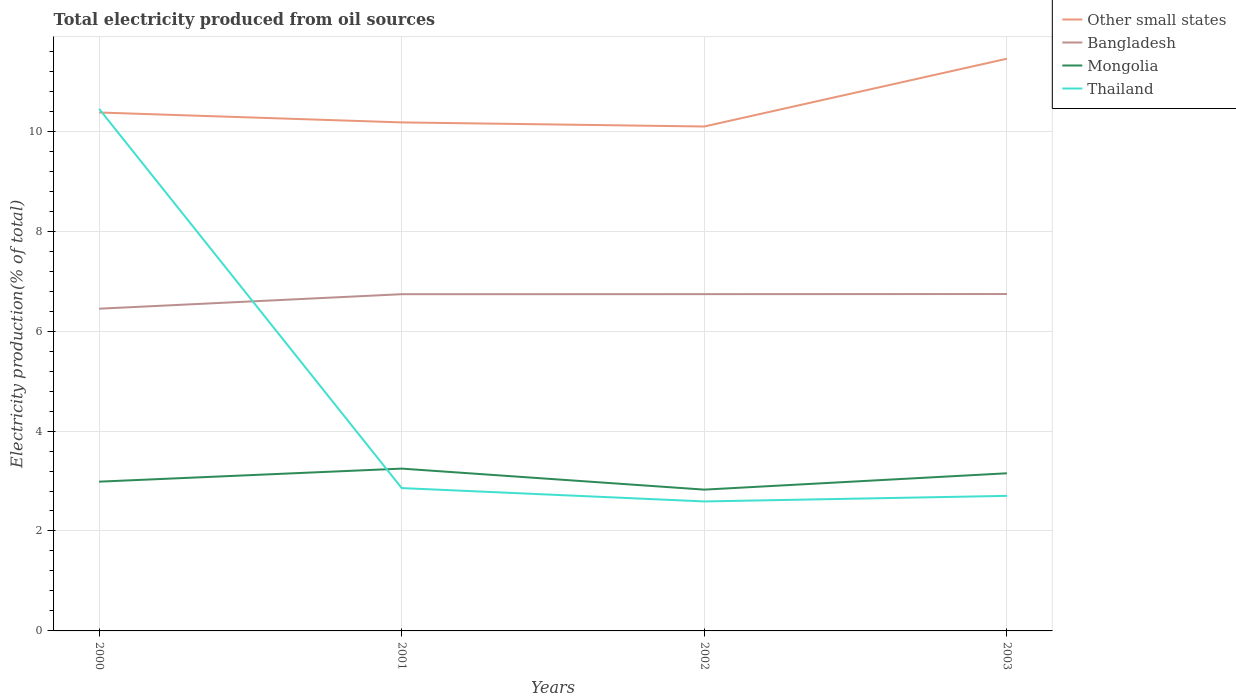Is the number of lines equal to the number of legend labels?
Make the answer very short. Yes. Across all years, what is the maximum total electricity produced in Bangladesh?
Ensure brevity in your answer.  6.45. In which year was the total electricity produced in Other small states maximum?
Ensure brevity in your answer.  2002. What is the total total electricity produced in Thailand in the graph?
Make the answer very short. 7.75. What is the difference between the highest and the second highest total electricity produced in Other small states?
Your answer should be compact. 1.36. What is the difference between the highest and the lowest total electricity produced in Thailand?
Give a very brief answer. 1. Is the total electricity produced in Bangladesh strictly greater than the total electricity produced in Mongolia over the years?
Ensure brevity in your answer.  No. How many lines are there?
Provide a succinct answer. 4. How many years are there in the graph?
Ensure brevity in your answer.  4. Are the values on the major ticks of Y-axis written in scientific E-notation?
Provide a short and direct response. No. Does the graph contain any zero values?
Provide a succinct answer. No. Does the graph contain grids?
Provide a short and direct response. Yes. Where does the legend appear in the graph?
Your answer should be compact. Top right. How are the legend labels stacked?
Your answer should be very brief. Vertical. What is the title of the graph?
Offer a very short reply. Total electricity produced from oil sources. Does "Mali" appear as one of the legend labels in the graph?
Your answer should be very brief. No. What is the Electricity production(% of total) in Other small states in 2000?
Keep it short and to the point. 10.37. What is the Electricity production(% of total) of Bangladesh in 2000?
Keep it short and to the point. 6.45. What is the Electricity production(% of total) of Mongolia in 2000?
Your response must be concise. 2.99. What is the Electricity production(% of total) of Thailand in 2000?
Provide a succinct answer. 10.45. What is the Electricity production(% of total) in Other small states in 2001?
Keep it short and to the point. 10.18. What is the Electricity production(% of total) of Bangladesh in 2001?
Make the answer very short. 6.74. What is the Electricity production(% of total) in Mongolia in 2001?
Offer a terse response. 3.25. What is the Electricity production(% of total) in Thailand in 2001?
Offer a very short reply. 2.86. What is the Electricity production(% of total) of Other small states in 2002?
Make the answer very short. 10.09. What is the Electricity production(% of total) of Bangladesh in 2002?
Give a very brief answer. 6.74. What is the Electricity production(% of total) of Mongolia in 2002?
Ensure brevity in your answer.  2.83. What is the Electricity production(% of total) of Thailand in 2002?
Your answer should be compact. 2.59. What is the Electricity production(% of total) in Other small states in 2003?
Your answer should be compact. 11.45. What is the Electricity production(% of total) of Bangladesh in 2003?
Offer a terse response. 6.74. What is the Electricity production(% of total) of Mongolia in 2003?
Your answer should be compact. 3.15. What is the Electricity production(% of total) of Thailand in 2003?
Offer a terse response. 2.7. Across all years, what is the maximum Electricity production(% of total) in Other small states?
Keep it short and to the point. 11.45. Across all years, what is the maximum Electricity production(% of total) of Bangladesh?
Ensure brevity in your answer.  6.74. Across all years, what is the maximum Electricity production(% of total) of Mongolia?
Your response must be concise. 3.25. Across all years, what is the maximum Electricity production(% of total) in Thailand?
Provide a short and direct response. 10.45. Across all years, what is the minimum Electricity production(% of total) in Other small states?
Your answer should be compact. 10.09. Across all years, what is the minimum Electricity production(% of total) in Bangladesh?
Your answer should be compact. 6.45. Across all years, what is the minimum Electricity production(% of total) of Mongolia?
Ensure brevity in your answer.  2.83. Across all years, what is the minimum Electricity production(% of total) in Thailand?
Give a very brief answer. 2.59. What is the total Electricity production(% of total) of Other small states in the graph?
Provide a short and direct response. 42.1. What is the total Electricity production(% of total) of Bangladesh in the graph?
Offer a very short reply. 26.67. What is the total Electricity production(% of total) in Mongolia in the graph?
Your answer should be very brief. 12.22. What is the total Electricity production(% of total) of Thailand in the graph?
Ensure brevity in your answer.  18.6. What is the difference between the Electricity production(% of total) of Other small states in 2000 and that in 2001?
Ensure brevity in your answer.  0.2. What is the difference between the Electricity production(% of total) in Bangladesh in 2000 and that in 2001?
Make the answer very short. -0.29. What is the difference between the Electricity production(% of total) of Mongolia in 2000 and that in 2001?
Offer a very short reply. -0.26. What is the difference between the Electricity production(% of total) in Thailand in 2000 and that in 2001?
Ensure brevity in your answer.  7.59. What is the difference between the Electricity production(% of total) of Other small states in 2000 and that in 2002?
Your answer should be very brief. 0.28. What is the difference between the Electricity production(% of total) of Bangladesh in 2000 and that in 2002?
Ensure brevity in your answer.  -0.29. What is the difference between the Electricity production(% of total) in Mongolia in 2000 and that in 2002?
Your response must be concise. 0.16. What is the difference between the Electricity production(% of total) of Thailand in 2000 and that in 2002?
Keep it short and to the point. 7.86. What is the difference between the Electricity production(% of total) of Other small states in 2000 and that in 2003?
Offer a terse response. -1.08. What is the difference between the Electricity production(% of total) in Bangladesh in 2000 and that in 2003?
Give a very brief answer. -0.29. What is the difference between the Electricity production(% of total) of Mongolia in 2000 and that in 2003?
Make the answer very short. -0.17. What is the difference between the Electricity production(% of total) of Thailand in 2000 and that in 2003?
Your response must be concise. 7.75. What is the difference between the Electricity production(% of total) of Other small states in 2001 and that in 2002?
Offer a very short reply. 0.08. What is the difference between the Electricity production(% of total) in Bangladesh in 2001 and that in 2002?
Your answer should be compact. -0. What is the difference between the Electricity production(% of total) of Mongolia in 2001 and that in 2002?
Offer a very short reply. 0.42. What is the difference between the Electricity production(% of total) in Thailand in 2001 and that in 2002?
Give a very brief answer. 0.27. What is the difference between the Electricity production(% of total) in Other small states in 2001 and that in 2003?
Provide a succinct answer. -1.27. What is the difference between the Electricity production(% of total) of Bangladesh in 2001 and that in 2003?
Your response must be concise. -0. What is the difference between the Electricity production(% of total) in Mongolia in 2001 and that in 2003?
Your answer should be very brief. 0.09. What is the difference between the Electricity production(% of total) in Thailand in 2001 and that in 2003?
Give a very brief answer. 0.16. What is the difference between the Electricity production(% of total) of Other small states in 2002 and that in 2003?
Your answer should be very brief. -1.36. What is the difference between the Electricity production(% of total) of Bangladesh in 2002 and that in 2003?
Provide a short and direct response. -0. What is the difference between the Electricity production(% of total) in Mongolia in 2002 and that in 2003?
Keep it short and to the point. -0.33. What is the difference between the Electricity production(% of total) in Thailand in 2002 and that in 2003?
Offer a very short reply. -0.11. What is the difference between the Electricity production(% of total) of Other small states in 2000 and the Electricity production(% of total) of Bangladesh in 2001?
Offer a terse response. 3.64. What is the difference between the Electricity production(% of total) in Other small states in 2000 and the Electricity production(% of total) in Mongolia in 2001?
Your response must be concise. 7.13. What is the difference between the Electricity production(% of total) of Other small states in 2000 and the Electricity production(% of total) of Thailand in 2001?
Provide a short and direct response. 7.52. What is the difference between the Electricity production(% of total) in Bangladesh in 2000 and the Electricity production(% of total) in Mongolia in 2001?
Offer a terse response. 3.2. What is the difference between the Electricity production(% of total) of Bangladesh in 2000 and the Electricity production(% of total) of Thailand in 2001?
Your answer should be compact. 3.59. What is the difference between the Electricity production(% of total) of Mongolia in 2000 and the Electricity production(% of total) of Thailand in 2001?
Give a very brief answer. 0.13. What is the difference between the Electricity production(% of total) in Other small states in 2000 and the Electricity production(% of total) in Bangladesh in 2002?
Offer a terse response. 3.63. What is the difference between the Electricity production(% of total) in Other small states in 2000 and the Electricity production(% of total) in Mongolia in 2002?
Offer a terse response. 7.55. What is the difference between the Electricity production(% of total) of Other small states in 2000 and the Electricity production(% of total) of Thailand in 2002?
Keep it short and to the point. 7.78. What is the difference between the Electricity production(% of total) in Bangladesh in 2000 and the Electricity production(% of total) in Mongolia in 2002?
Offer a terse response. 3.62. What is the difference between the Electricity production(% of total) of Bangladesh in 2000 and the Electricity production(% of total) of Thailand in 2002?
Your answer should be very brief. 3.86. What is the difference between the Electricity production(% of total) of Mongolia in 2000 and the Electricity production(% of total) of Thailand in 2002?
Your response must be concise. 0.4. What is the difference between the Electricity production(% of total) of Other small states in 2000 and the Electricity production(% of total) of Bangladesh in 2003?
Provide a succinct answer. 3.63. What is the difference between the Electricity production(% of total) of Other small states in 2000 and the Electricity production(% of total) of Mongolia in 2003?
Make the answer very short. 7.22. What is the difference between the Electricity production(% of total) of Other small states in 2000 and the Electricity production(% of total) of Thailand in 2003?
Give a very brief answer. 7.67. What is the difference between the Electricity production(% of total) of Bangladesh in 2000 and the Electricity production(% of total) of Mongolia in 2003?
Your response must be concise. 3.29. What is the difference between the Electricity production(% of total) in Bangladesh in 2000 and the Electricity production(% of total) in Thailand in 2003?
Your answer should be very brief. 3.75. What is the difference between the Electricity production(% of total) of Mongolia in 2000 and the Electricity production(% of total) of Thailand in 2003?
Keep it short and to the point. 0.28. What is the difference between the Electricity production(% of total) of Other small states in 2001 and the Electricity production(% of total) of Bangladesh in 2002?
Provide a short and direct response. 3.44. What is the difference between the Electricity production(% of total) of Other small states in 2001 and the Electricity production(% of total) of Mongolia in 2002?
Your answer should be compact. 7.35. What is the difference between the Electricity production(% of total) in Other small states in 2001 and the Electricity production(% of total) in Thailand in 2002?
Your response must be concise. 7.59. What is the difference between the Electricity production(% of total) of Bangladesh in 2001 and the Electricity production(% of total) of Mongolia in 2002?
Ensure brevity in your answer.  3.91. What is the difference between the Electricity production(% of total) in Bangladesh in 2001 and the Electricity production(% of total) in Thailand in 2002?
Ensure brevity in your answer.  4.15. What is the difference between the Electricity production(% of total) in Mongolia in 2001 and the Electricity production(% of total) in Thailand in 2002?
Your answer should be very brief. 0.66. What is the difference between the Electricity production(% of total) of Other small states in 2001 and the Electricity production(% of total) of Bangladesh in 2003?
Ensure brevity in your answer.  3.43. What is the difference between the Electricity production(% of total) in Other small states in 2001 and the Electricity production(% of total) in Mongolia in 2003?
Your answer should be very brief. 7.02. What is the difference between the Electricity production(% of total) in Other small states in 2001 and the Electricity production(% of total) in Thailand in 2003?
Your answer should be compact. 7.47. What is the difference between the Electricity production(% of total) in Bangladesh in 2001 and the Electricity production(% of total) in Mongolia in 2003?
Provide a short and direct response. 3.58. What is the difference between the Electricity production(% of total) in Bangladesh in 2001 and the Electricity production(% of total) in Thailand in 2003?
Your response must be concise. 4.04. What is the difference between the Electricity production(% of total) in Mongolia in 2001 and the Electricity production(% of total) in Thailand in 2003?
Give a very brief answer. 0.55. What is the difference between the Electricity production(% of total) of Other small states in 2002 and the Electricity production(% of total) of Bangladesh in 2003?
Make the answer very short. 3.35. What is the difference between the Electricity production(% of total) of Other small states in 2002 and the Electricity production(% of total) of Mongolia in 2003?
Provide a short and direct response. 6.94. What is the difference between the Electricity production(% of total) in Other small states in 2002 and the Electricity production(% of total) in Thailand in 2003?
Keep it short and to the point. 7.39. What is the difference between the Electricity production(% of total) of Bangladesh in 2002 and the Electricity production(% of total) of Mongolia in 2003?
Provide a succinct answer. 3.58. What is the difference between the Electricity production(% of total) in Bangladesh in 2002 and the Electricity production(% of total) in Thailand in 2003?
Offer a very short reply. 4.04. What is the difference between the Electricity production(% of total) of Mongolia in 2002 and the Electricity production(% of total) of Thailand in 2003?
Make the answer very short. 0.12. What is the average Electricity production(% of total) of Other small states per year?
Provide a short and direct response. 10.52. What is the average Electricity production(% of total) in Bangladesh per year?
Ensure brevity in your answer.  6.67. What is the average Electricity production(% of total) in Mongolia per year?
Offer a terse response. 3.05. What is the average Electricity production(% of total) of Thailand per year?
Your answer should be compact. 4.65. In the year 2000, what is the difference between the Electricity production(% of total) in Other small states and Electricity production(% of total) in Bangladesh?
Make the answer very short. 3.93. In the year 2000, what is the difference between the Electricity production(% of total) of Other small states and Electricity production(% of total) of Mongolia?
Your response must be concise. 7.39. In the year 2000, what is the difference between the Electricity production(% of total) of Other small states and Electricity production(% of total) of Thailand?
Ensure brevity in your answer.  -0.07. In the year 2000, what is the difference between the Electricity production(% of total) in Bangladesh and Electricity production(% of total) in Mongolia?
Keep it short and to the point. 3.46. In the year 2000, what is the difference between the Electricity production(% of total) of Bangladesh and Electricity production(% of total) of Thailand?
Your answer should be very brief. -4. In the year 2000, what is the difference between the Electricity production(% of total) in Mongolia and Electricity production(% of total) in Thailand?
Keep it short and to the point. -7.46. In the year 2001, what is the difference between the Electricity production(% of total) in Other small states and Electricity production(% of total) in Bangladesh?
Your response must be concise. 3.44. In the year 2001, what is the difference between the Electricity production(% of total) of Other small states and Electricity production(% of total) of Mongolia?
Offer a very short reply. 6.93. In the year 2001, what is the difference between the Electricity production(% of total) of Other small states and Electricity production(% of total) of Thailand?
Your response must be concise. 7.32. In the year 2001, what is the difference between the Electricity production(% of total) of Bangladesh and Electricity production(% of total) of Mongolia?
Give a very brief answer. 3.49. In the year 2001, what is the difference between the Electricity production(% of total) of Bangladesh and Electricity production(% of total) of Thailand?
Your response must be concise. 3.88. In the year 2001, what is the difference between the Electricity production(% of total) in Mongolia and Electricity production(% of total) in Thailand?
Your response must be concise. 0.39. In the year 2002, what is the difference between the Electricity production(% of total) in Other small states and Electricity production(% of total) in Bangladesh?
Offer a very short reply. 3.35. In the year 2002, what is the difference between the Electricity production(% of total) of Other small states and Electricity production(% of total) of Mongolia?
Your answer should be very brief. 7.27. In the year 2002, what is the difference between the Electricity production(% of total) in Other small states and Electricity production(% of total) in Thailand?
Give a very brief answer. 7.5. In the year 2002, what is the difference between the Electricity production(% of total) of Bangladesh and Electricity production(% of total) of Mongolia?
Offer a very short reply. 3.91. In the year 2002, what is the difference between the Electricity production(% of total) in Bangladesh and Electricity production(% of total) in Thailand?
Provide a succinct answer. 4.15. In the year 2002, what is the difference between the Electricity production(% of total) of Mongolia and Electricity production(% of total) of Thailand?
Your response must be concise. 0.24. In the year 2003, what is the difference between the Electricity production(% of total) of Other small states and Electricity production(% of total) of Bangladesh?
Ensure brevity in your answer.  4.71. In the year 2003, what is the difference between the Electricity production(% of total) of Other small states and Electricity production(% of total) of Mongolia?
Provide a succinct answer. 8.3. In the year 2003, what is the difference between the Electricity production(% of total) of Other small states and Electricity production(% of total) of Thailand?
Provide a short and direct response. 8.75. In the year 2003, what is the difference between the Electricity production(% of total) in Bangladesh and Electricity production(% of total) in Mongolia?
Ensure brevity in your answer.  3.59. In the year 2003, what is the difference between the Electricity production(% of total) of Bangladesh and Electricity production(% of total) of Thailand?
Offer a terse response. 4.04. In the year 2003, what is the difference between the Electricity production(% of total) of Mongolia and Electricity production(% of total) of Thailand?
Your answer should be very brief. 0.45. What is the ratio of the Electricity production(% of total) in Other small states in 2000 to that in 2001?
Give a very brief answer. 1.02. What is the ratio of the Electricity production(% of total) of Bangladesh in 2000 to that in 2001?
Your answer should be very brief. 0.96. What is the ratio of the Electricity production(% of total) in Mongolia in 2000 to that in 2001?
Make the answer very short. 0.92. What is the ratio of the Electricity production(% of total) of Thailand in 2000 to that in 2001?
Provide a short and direct response. 3.65. What is the ratio of the Electricity production(% of total) of Other small states in 2000 to that in 2002?
Your response must be concise. 1.03. What is the ratio of the Electricity production(% of total) of Bangladesh in 2000 to that in 2002?
Your answer should be very brief. 0.96. What is the ratio of the Electricity production(% of total) of Mongolia in 2000 to that in 2002?
Provide a short and direct response. 1.06. What is the ratio of the Electricity production(% of total) in Thailand in 2000 to that in 2002?
Offer a terse response. 4.03. What is the ratio of the Electricity production(% of total) of Other small states in 2000 to that in 2003?
Make the answer very short. 0.91. What is the ratio of the Electricity production(% of total) in Bangladesh in 2000 to that in 2003?
Your answer should be very brief. 0.96. What is the ratio of the Electricity production(% of total) of Mongolia in 2000 to that in 2003?
Offer a very short reply. 0.95. What is the ratio of the Electricity production(% of total) in Thailand in 2000 to that in 2003?
Provide a succinct answer. 3.87. What is the ratio of the Electricity production(% of total) of Other small states in 2001 to that in 2002?
Provide a succinct answer. 1.01. What is the ratio of the Electricity production(% of total) in Mongolia in 2001 to that in 2002?
Give a very brief answer. 1.15. What is the ratio of the Electricity production(% of total) in Thailand in 2001 to that in 2002?
Make the answer very short. 1.1. What is the ratio of the Electricity production(% of total) in Other small states in 2001 to that in 2003?
Your answer should be compact. 0.89. What is the ratio of the Electricity production(% of total) in Mongolia in 2001 to that in 2003?
Provide a short and direct response. 1.03. What is the ratio of the Electricity production(% of total) of Thailand in 2001 to that in 2003?
Give a very brief answer. 1.06. What is the ratio of the Electricity production(% of total) in Other small states in 2002 to that in 2003?
Your response must be concise. 0.88. What is the ratio of the Electricity production(% of total) of Mongolia in 2002 to that in 2003?
Provide a short and direct response. 0.9. What is the ratio of the Electricity production(% of total) of Thailand in 2002 to that in 2003?
Give a very brief answer. 0.96. What is the difference between the highest and the second highest Electricity production(% of total) in Other small states?
Your answer should be very brief. 1.08. What is the difference between the highest and the second highest Electricity production(% of total) in Bangladesh?
Make the answer very short. 0. What is the difference between the highest and the second highest Electricity production(% of total) in Mongolia?
Provide a short and direct response. 0.09. What is the difference between the highest and the second highest Electricity production(% of total) of Thailand?
Ensure brevity in your answer.  7.59. What is the difference between the highest and the lowest Electricity production(% of total) of Other small states?
Provide a short and direct response. 1.36. What is the difference between the highest and the lowest Electricity production(% of total) of Bangladesh?
Ensure brevity in your answer.  0.29. What is the difference between the highest and the lowest Electricity production(% of total) in Mongolia?
Provide a succinct answer. 0.42. What is the difference between the highest and the lowest Electricity production(% of total) in Thailand?
Your answer should be compact. 7.86. 